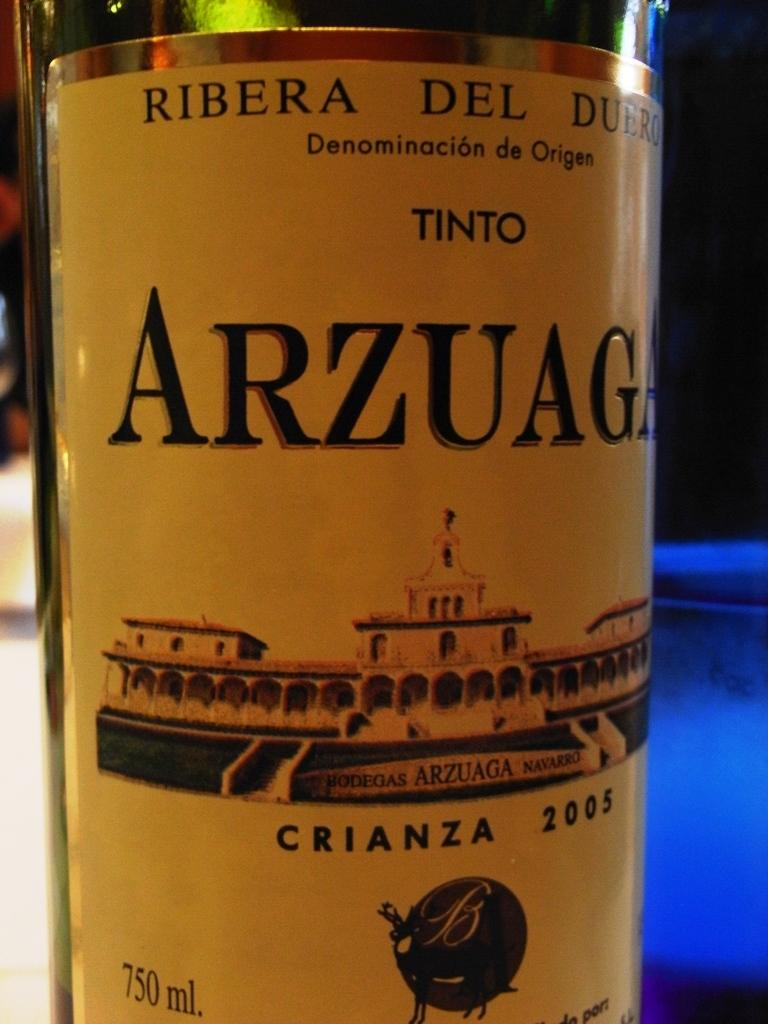What is the main object in the image? There is a wine bottle in the image. Can you describe the label on the wine bottle? The wine bottle has a black and yellow label. Who is the owner of the snail in the image? There is no snail present in the image, so it is not possible to determine the owner. 